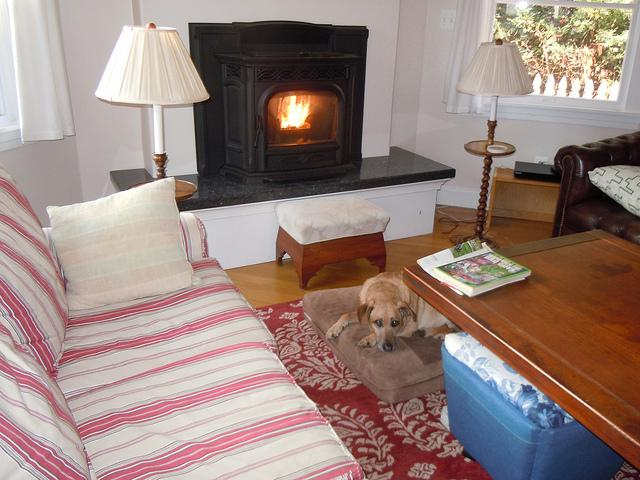What is the dog lying on? Please explain your reasoning. dog bed. The object is square and allows plenty of space for a large breed to get comfortable on it. 